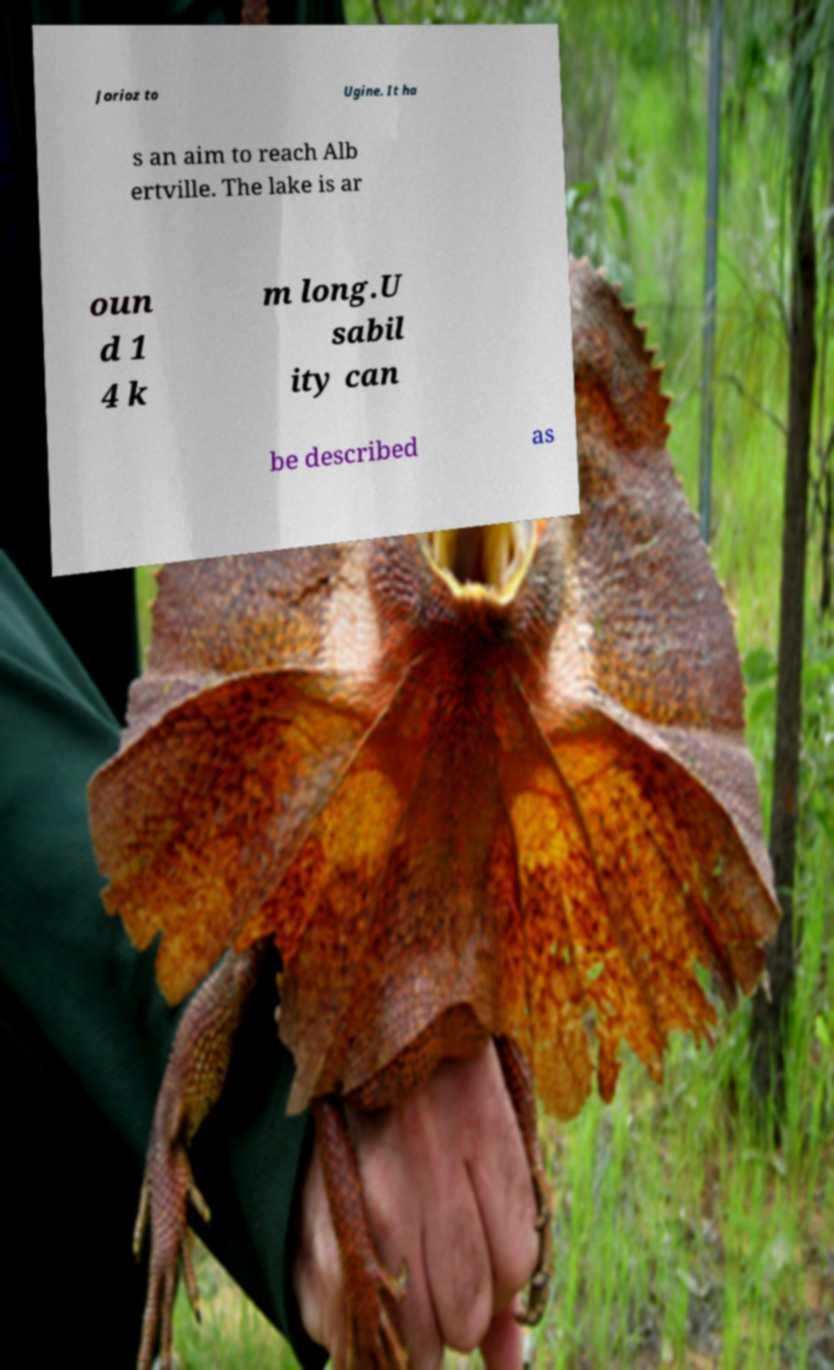Please identify and transcribe the text found in this image. Jorioz to Ugine. It ha s an aim to reach Alb ertville. The lake is ar oun d 1 4 k m long.U sabil ity can be described as 